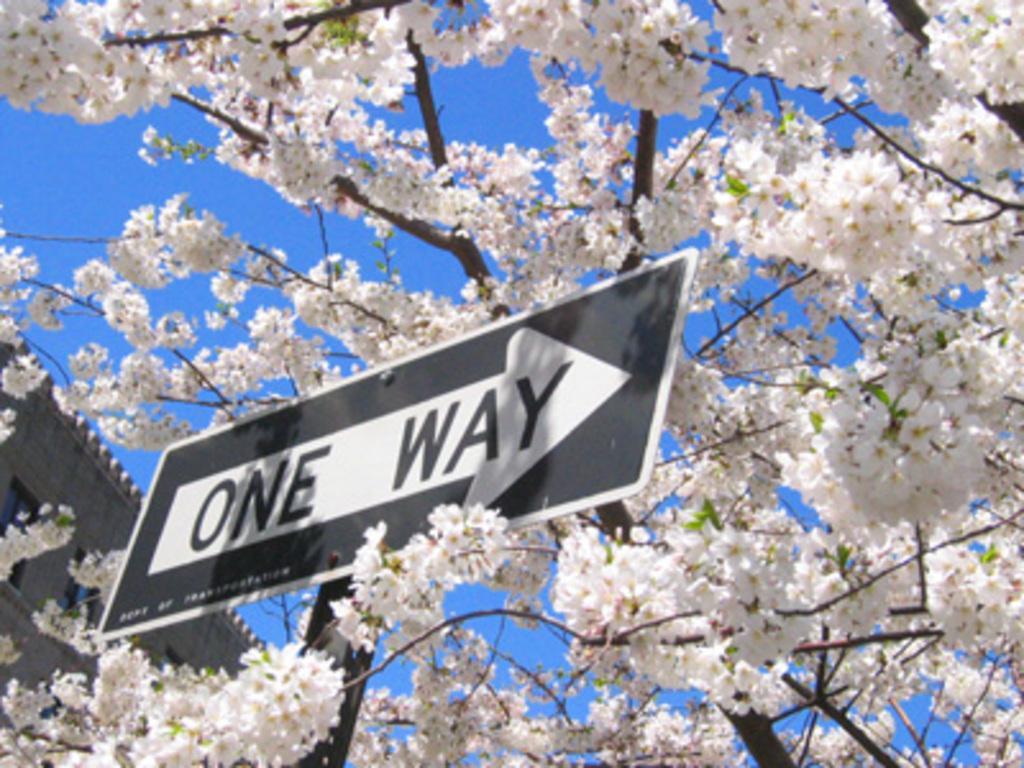In one or two sentences, can you explain what this image depicts? In this image there is a sign board, a tree with flowers, a building and the sky. 